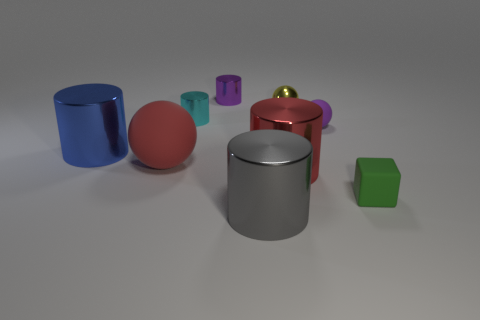Subtract all gray cylinders. How many cylinders are left? 4 Subtract all large red cylinders. How many cylinders are left? 4 Subtract all brown cylinders. Subtract all cyan spheres. How many cylinders are left? 5 Add 1 balls. How many objects exist? 10 Subtract all cylinders. How many objects are left? 4 Subtract 1 red cylinders. How many objects are left? 8 Subtract all rubber blocks. Subtract all large blue metallic cylinders. How many objects are left? 7 Add 1 purple objects. How many purple objects are left? 3 Add 8 purple balls. How many purple balls exist? 9 